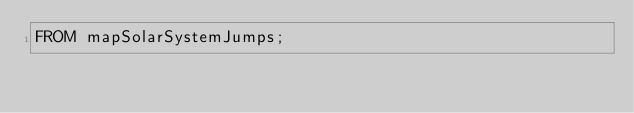Convert code to text. <code><loc_0><loc_0><loc_500><loc_500><_SQL_>FROM mapSolarSystemJumps;
</code> 